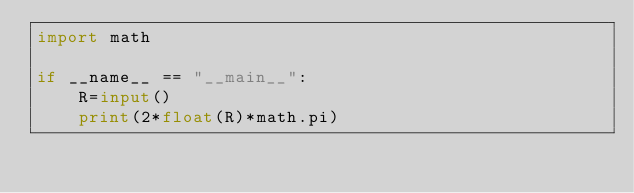Convert code to text. <code><loc_0><loc_0><loc_500><loc_500><_Python_>import math

if __name__ == "__main__":
    R=input()
    print(2*float(R)*math.pi)</code> 